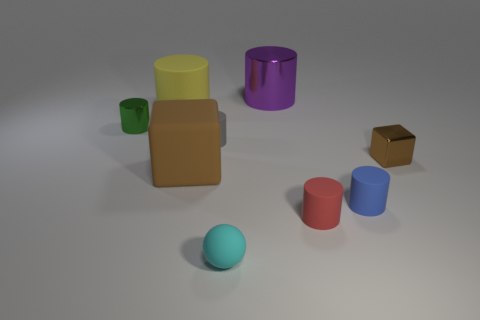Subtract all small green cylinders. How many cylinders are left? 5 Subtract 1 cubes. How many cubes are left? 1 Add 1 blue matte cubes. How many objects exist? 10 Subtract all blue cylinders. How many cylinders are left? 5 Subtract all balls. How many objects are left? 8 Add 2 small cyan balls. How many small cyan balls exist? 3 Subtract 0 brown cylinders. How many objects are left? 9 Subtract all brown cylinders. Subtract all purple blocks. How many cylinders are left? 6 Subtract all tiny brown cubes. Subtract all big rubber objects. How many objects are left? 6 Add 2 matte blocks. How many matte blocks are left? 3 